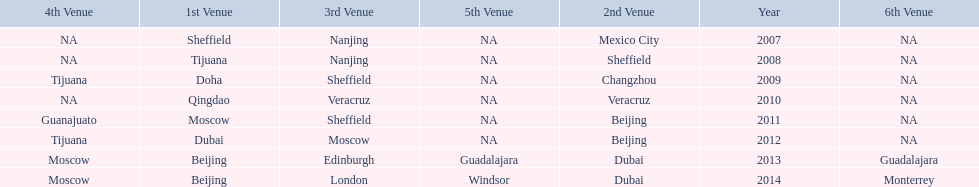What was the last year where tijuana was a venue? 2012. 